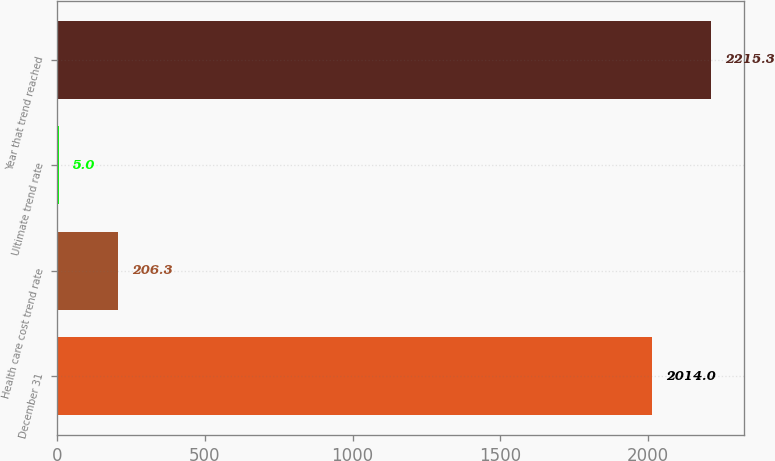Convert chart. <chart><loc_0><loc_0><loc_500><loc_500><bar_chart><fcel>December 31<fcel>Health care cost trend rate<fcel>Ultimate trend rate<fcel>Year that trend reached<nl><fcel>2014<fcel>206.3<fcel>5<fcel>2215.3<nl></chart> 